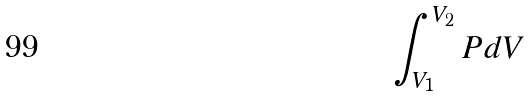<formula> <loc_0><loc_0><loc_500><loc_500>\int _ { V _ { 1 } } ^ { V _ { 2 } } P d V</formula> 